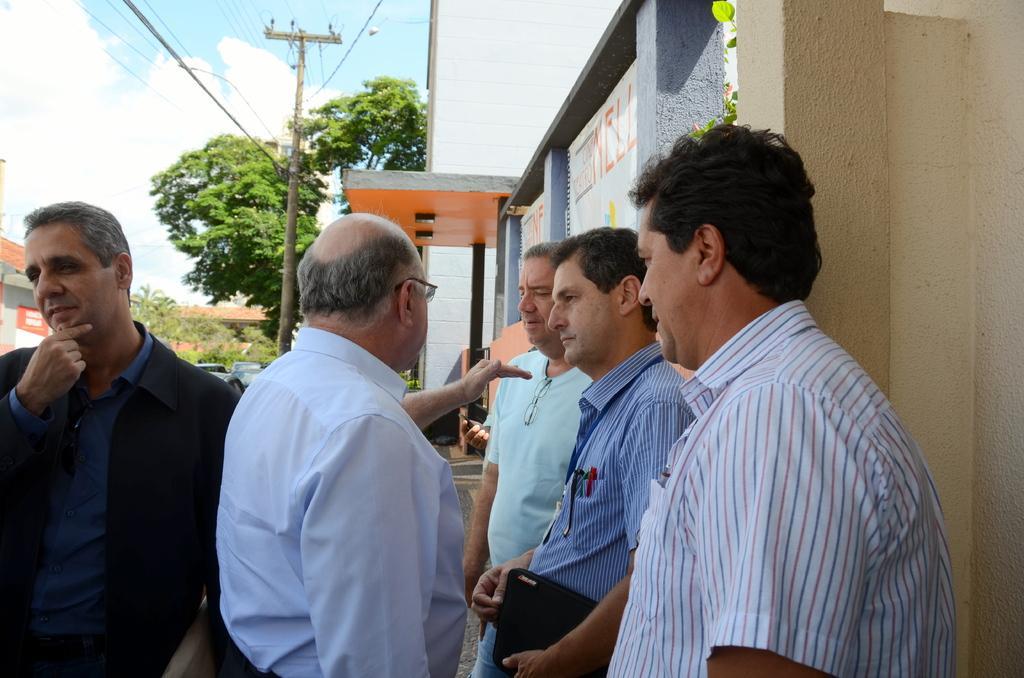Can you describe this image briefly? In this image we can see a group of people. There are many trees in the image. We can see advertising boards at the right side of the image. There is an advertising board at the left side of the image. We can see the clouds in the sky. There are many cables connected to a pole. There are few buildings in the image. 